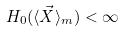<formula> <loc_0><loc_0><loc_500><loc_500>H _ { 0 } ( \langle \vec { X } \rangle _ { m } ) < \infty</formula> 